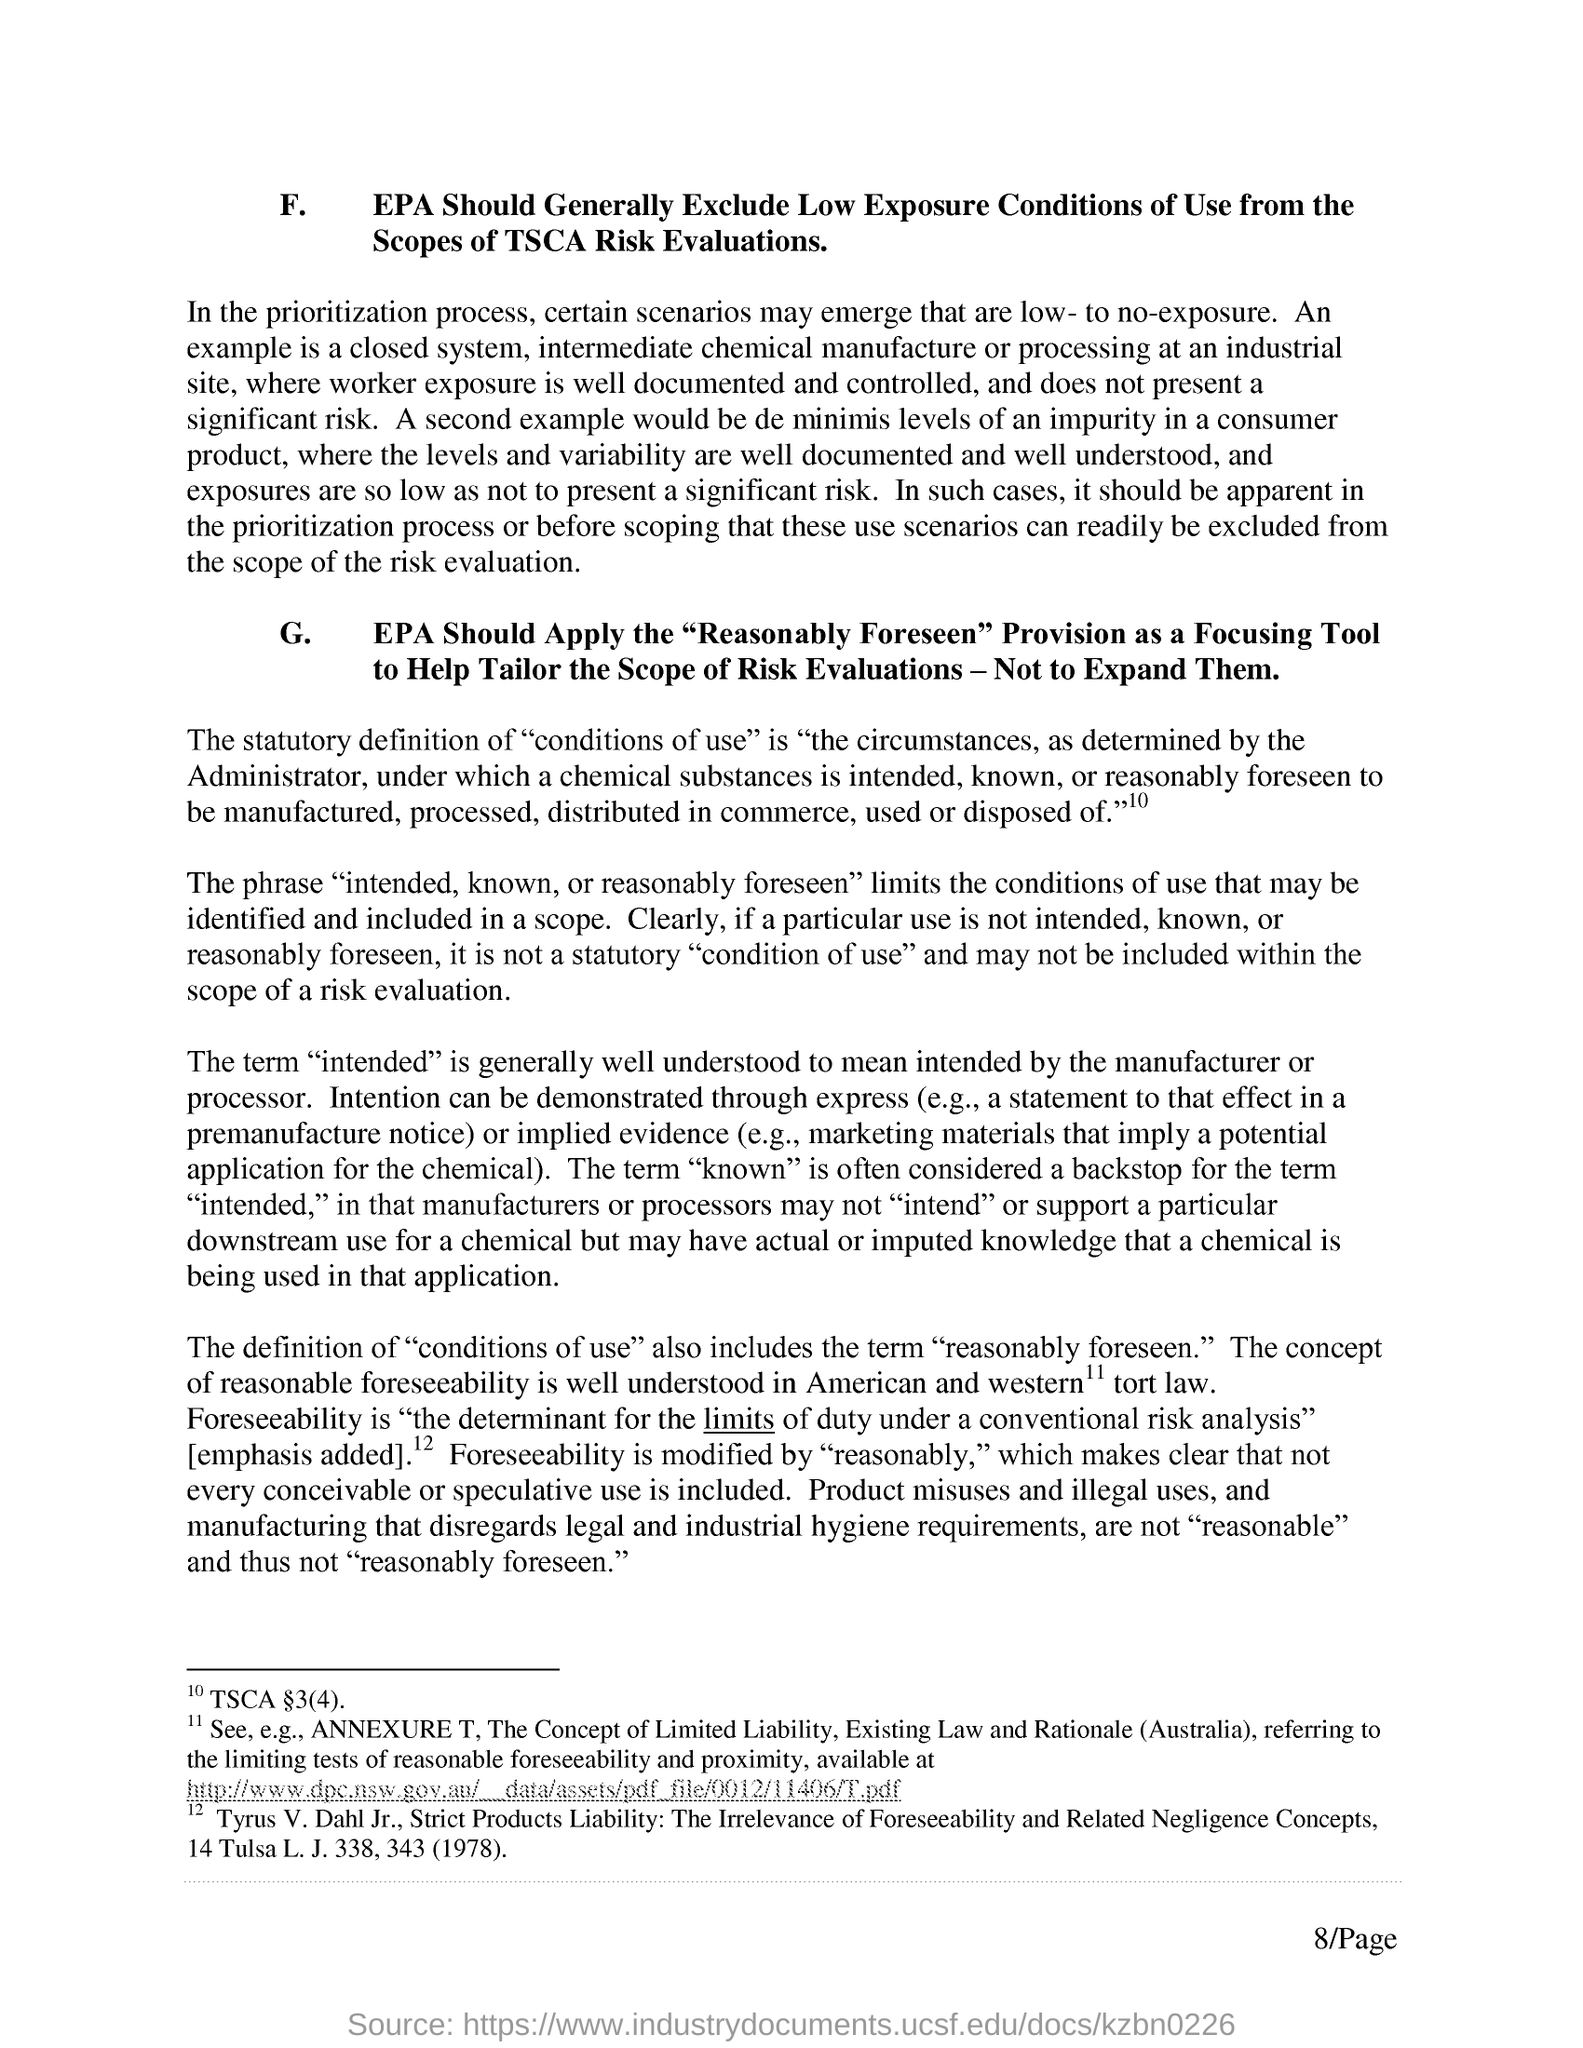Define Foreseeability.
Keep it short and to the point. Is "the determinant for the limits of duty under a conventional risk analysis". What should EPA exclude from the Scopes of TSCA Risk Evaluations?
Keep it short and to the point. Exclude Low Exposure Conditions of Use. Which Provision should be applied as a focusing tool by EPA?
Offer a terse response. EPA Should Apply the "Reasonably Foreseen" Provision. 